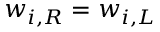Convert formula to latex. <formula><loc_0><loc_0><loc_500><loc_500>w _ { i , R } = w _ { i , L }</formula> 